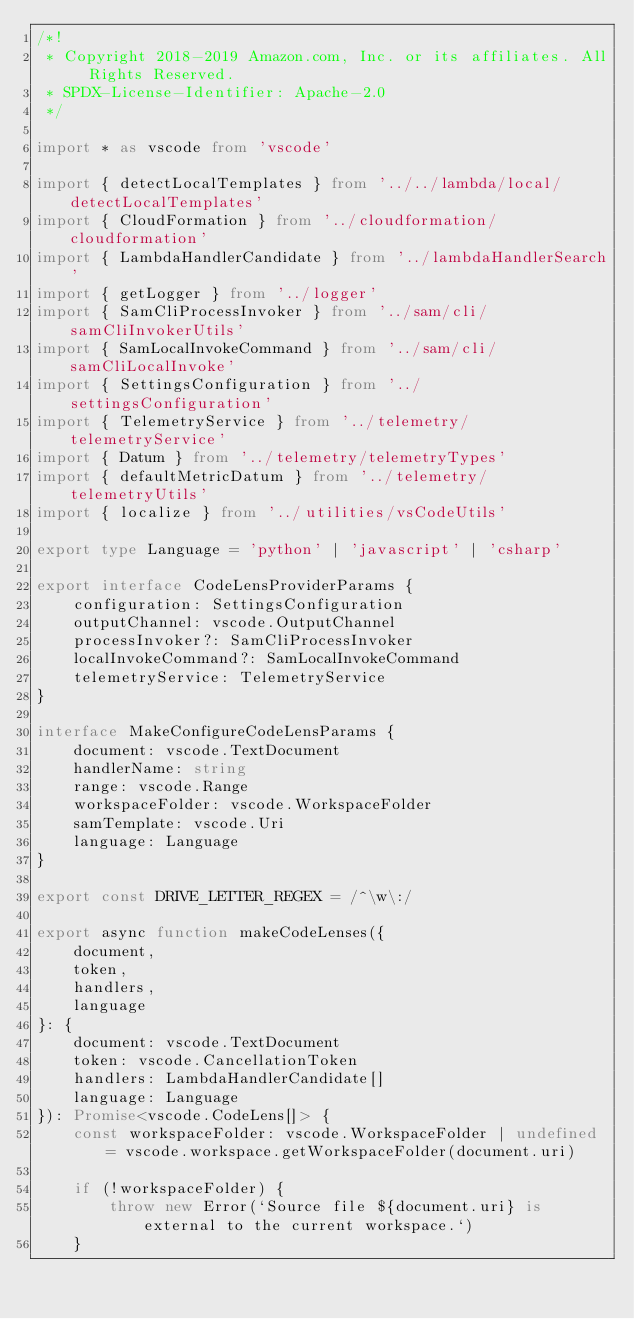Convert code to text. <code><loc_0><loc_0><loc_500><loc_500><_TypeScript_>/*!
 * Copyright 2018-2019 Amazon.com, Inc. or its affiliates. All Rights Reserved.
 * SPDX-License-Identifier: Apache-2.0
 */

import * as vscode from 'vscode'

import { detectLocalTemplates } from '../../lambda/local/detectLocalTemplates'
import { CloudFormation } from '../cloudformation/cloudformation'
import { LambdaHandlerCandidate } from '../lambdaHandlerSearch'
import { getLogger } from '../logger'
import { SamCliProcessInvoker } from '../sam/cli/samCliInvokerUtils'
import { SamLocalInvokeCommand } from '../sam/cli/samCliLocalInvoke'
import { SettingsConfiguration } from '../settingsConfiguration'
import { TelemetryService } from '../telemetry/telemetryService'
import { Datum } from '../telemetry/telemetryTypes'
import { defaultMetricDatum } from '../telemetry/telemetryUtils'
import { localize } from '../utilities/vsCodeUtils'

export type Language = 'python' | 'javascript' | 'csharp'

export interface CodeLensProviderParams {
    configuration: SettingsConfiguration
    outputChannel: vscode.OutputChannel
    processInvoker?: SamCliProcessInvoker
    localInvokeCommand?: SamLocalInvokeCommand
    telemetryService: TelemetryService
}

interface MakeConfigureCodeLensParams {
    document: vscode.TextDocument
    handlerName: string
    range: vscode.Range
    workspaceFolder: vscode.WorkspaceFolder
    samTemplate: vscode.Uri
    language: Language
}

export const DRIVE_LETTER_REGEX = /^\w\:/

export async function makeCodeLenses({
    document,
    token,
    handlers,
    language
}: {
    document: vscode.TextDocument
    token: vscode.CancellationToken
    handlers: LambdaHandlerCandidate[]
    language: Language
}): Promise<vscode.CodeLens[]> {
    const workspaceFolder: vscode.WorkspaceFolder | undefined = vscode.workspace.getWorkspaceFolder(document.uri)

    if (!workspaceFolder) {
        throw new Error(`Source file ${document.uri} is external to the current workspace.`)
    }
</code> 